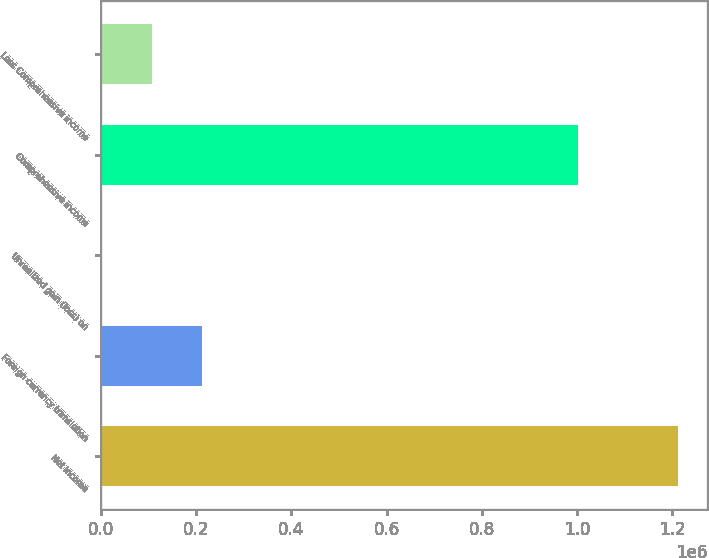<chart> <loc_0><loc_0><loc_500><loc_500><bar_chart><fcel>Net income<fcel>Foreign currency translation<fcel>Unrealized gain (loss) on<fcel>Comprehensive income<fcel>Less Comprehensive income<nl><fcel>1.21346e+06<fcel>211996<fcel>212<fcel>1.00168e+06<fcel>106104<nl></chart> 